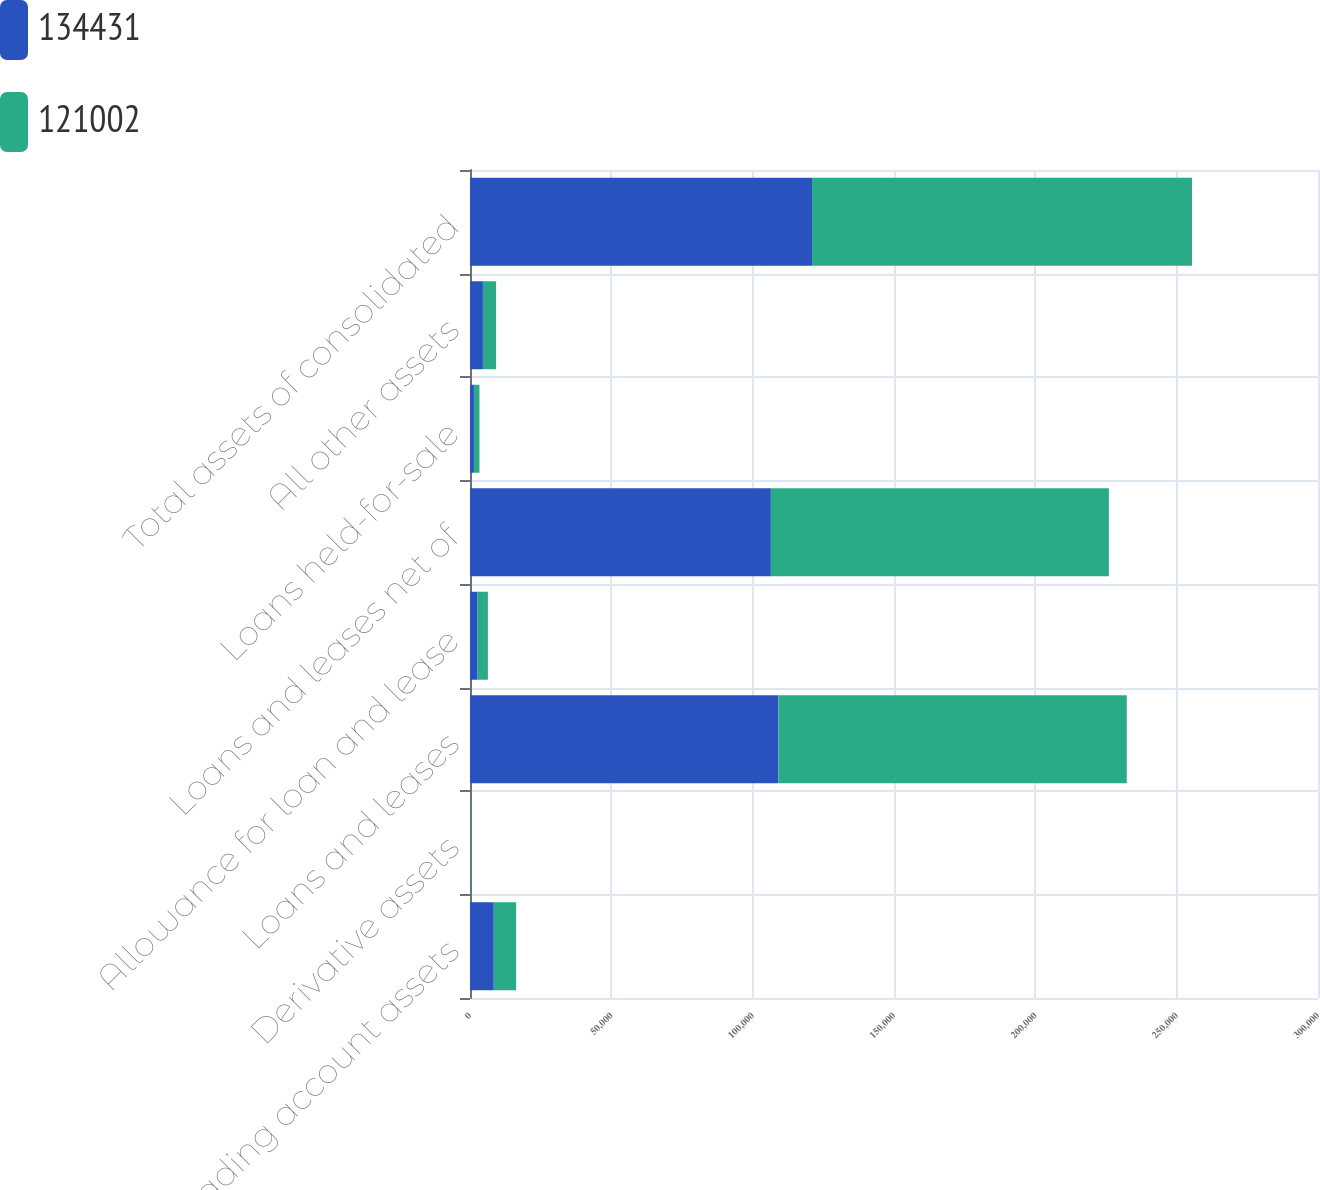<chart> <loc_0><loc_0><loc_500><loc_500><stacked_bar_chart><ecel><fcel>Trading account assets<fcel>Derivative assets<fcel>Loans and leases<fcel>Allowance for loan and lease<fcel>Loans and leases net of<fcel>Loans held-for-sale<fcel>All other assets<fcel>Total assets of consolidated<nl><fcel>134431<fcel>8412<fcel>185<fcel>109118<fcel>2674<fcel>106444<fcel>1384<fcel>4577<fcel>121002<nl><fcel>121002<fcel>7906<fcel>333<fcel>123227<fcel>3658<fcel>119569<fcel>1969<fcel>4654<fcel>134431<nl></chart> 